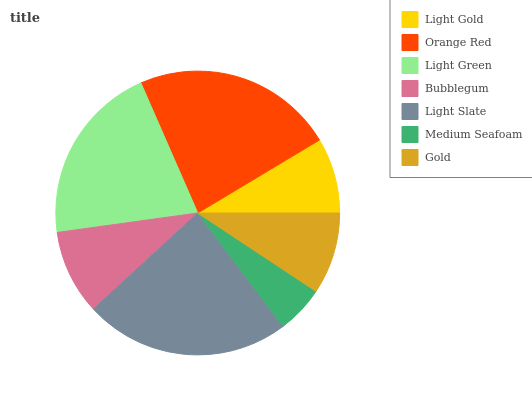Is Medium Seafoam the minimum?
Answer yes or no. Yes. Is Light Slate the maximum?
Answer yes or no. Yes. Is Orange Red the minimum?
Answer yes or no. No. Is Orange Red the maximum?
Answer yes or no. No. Is Orange Red greater than Light Gold?
Answer yes or no. Yes. Is Light Gold less than Orange Red?
Answer yes or no. Yes. Is Light Gold greater than Orange Red?
Answer yes or no. No. Is Orange Red less than Light Gold?
Answer yes or no. No. Is Bubblegum the high median?
Answer yes or no. Yes. Is Bubblegum the low median?
Answer yes or no. Yes. Is Light Green the high median?
Answer yes or no. No. Is Light Slate the low median?
Answer yes or no. No. 